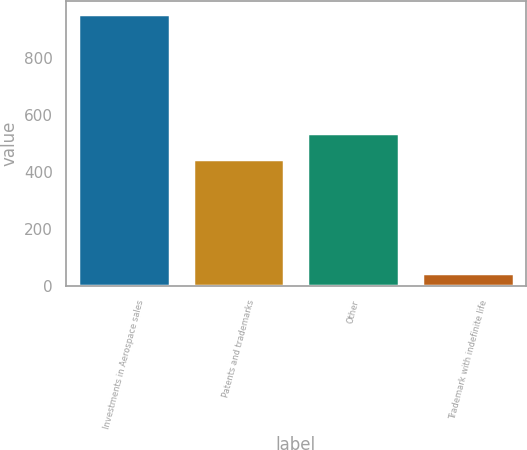Convert chart to OTSL. <chart><loc_0><loc_0><loc_500><loc_500><bar_chart><fcel>Investments in Aerospace sales<fcel>Patents and trademarks<fcel>Other<fcel>Trademark with indefinite life<nl><fcel>952<fcel>445<fcel>535.6<fcel>46<nl></chart> 